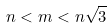<formula> <loc_0><loc_0><loc_500><loc_500>n < m < n { \sqrt { 3 } }</formula> 